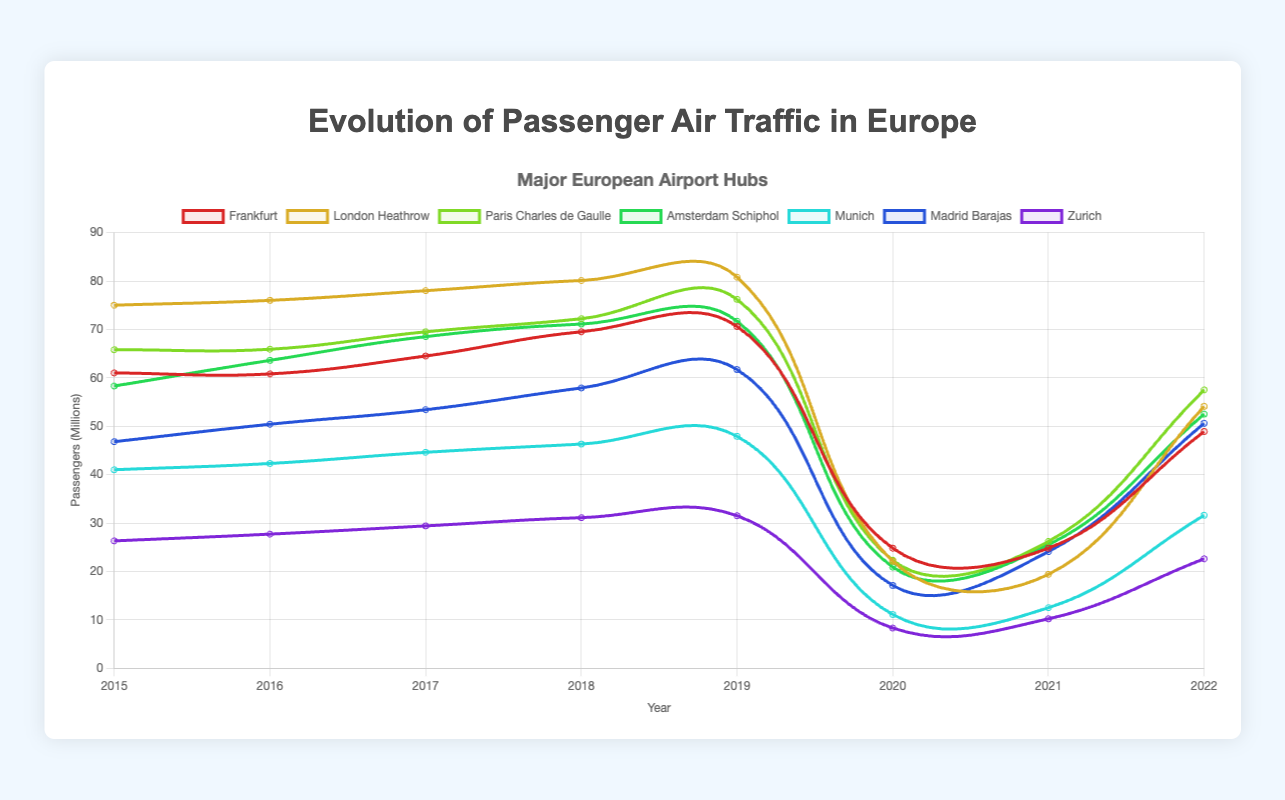What year did Frankfurt experience the lowest number of passengers? To determine Frankfurt's lowest number of passengers, look at Frankfurt's line in the graph and identify the year with the minimum value. Frankfurt had its lowest passenger number in 2020 with 24.8 million passengers.
Answer: 2020 Which airport showed the highest recovery in passenger numbers from 2021 to 2022? To determine the highest recovery, find the airport with the largest increase in passengers from 2021 to 2022. For each airport, deduct the 2021 value from the 2022 value and compare the differences. Paris Charles de Gaulle showed the highest increase from 26.2 million in 2021 to 57.5 million in 2022.
Answer: Paris Charles de Gaulle Compare the passenger numbers of London Heathrow and Paris Charles de Gaulle in 2019. Which one had more passengers? To compare passenger numbers, look at the values for London Heathrow and Paris Charles de Gaulle in 2019. London Heathrow had 80.8 million passengers, and Paris Charles de Gaulle had 76.2 million passengers. London Heathrow had more passengers.
Answer: London Heathrow What is the total number of passengers for Munich from 2015 to 2019? Sum the passenger numbers for Munich from 2015 to 2019. The values are 41.0, 42.3, 44.6, 46.3, and 47.9 million. Adding these numbers gives: 41.0 + 42.3 + 44.6 + 46.3 + 47.9 = 222.1 million.
Answer: 222.1 million In which year did Amsterdam Schiphol experience the highest number of passengers? Identify the peak value in Amsterdam Schiphol's line in the graph. The highest number of passengers for Amsterdam Schiphol was in 2019, with 71.7 million.
Answer: 2019 How did the total passenger count across all airports change from 2019 to 2020? Calculate the total passengers for all airports in 2019 and 2020, then find the difference. 2019 totals: Frankfurt 70.6 + London Heathrow 80.8 + Paris Charles de Gaulle 76.2 + Amsterdam Schiphol 71.7 + Munich 47.9 + Madrid Barajas 61.7 + Zurich 31.5 = 440.4 million. 2020 totals: Frankfurt 24.8 + London Heathrow 22.1 + Paris Charles de Gaulle 22.3 + Amsterdam Schiphol 20.9 + Munich 11.1 + Madrid Barajas 17.1 + Zurich 8.3 = 126.6 million. The decrease is 440.4 - 126.6 = 313.8 million.
Answer: 313.8 million decrease Which airport had the smallest decline in passenger traffic from 2019 to 2020? To find the smallest decline, calculate the difference in passengers for each airport from 2019 to 2020 and identify the smallest value. For Frankfurt, the decline is 70.6 - 24.8 = 45.8 million. Similarly, calculate for the others. Zurich had the smallest decline from 31.5 in 2019 to 8.3 in 2020, which is 31.5 - 8.3 = 23.2 million.
Answer: Zurich By what percentage did passenger numbers decrease for Frankfurt from 2019 to 2020? Calculate the percentage decrease using the formula: [(Old Number - New Number) / Old Number] * 100. For Frankfurt: [(70.6 - 24.8) / 70.6] * 100 = 64.87%.
Answer: 64.87% Combine the passenger numbers for Paris Charles de Gaulle and Munich in 2022. What is the total? Add the 2022 passenger numbers for Paris Charles de Gaulle (57.5 million) and Munich (31.6 million). The total is 57.5 + 31.6 = 89.1 million.
Answer: 89.1 million 